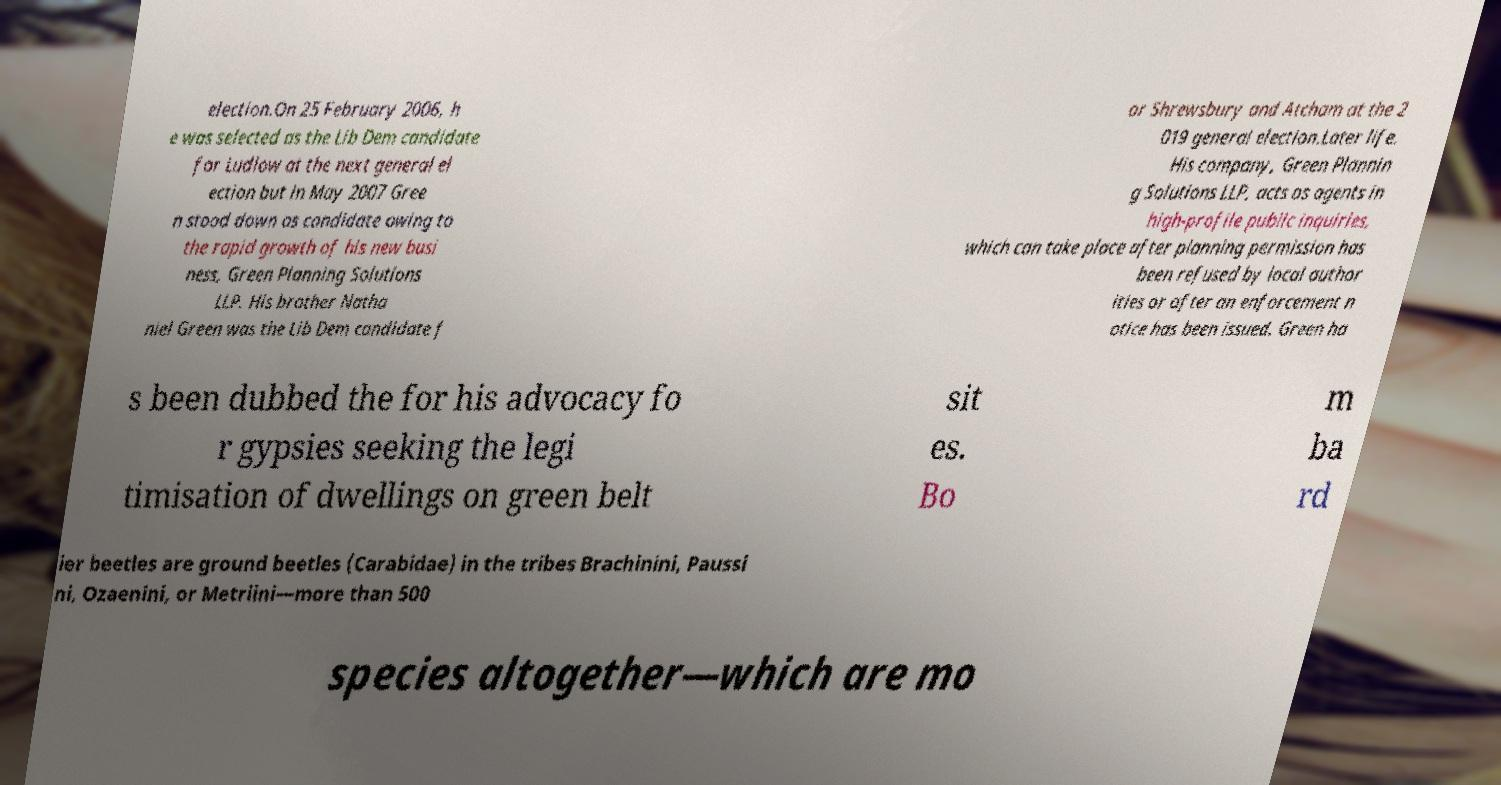What messages or text are displayed in this image? I need them in a readable, typed format. election.On 25 February 2006, h e was selected as the Lib Dem candidate for Ludlow at the next general el ection but in May 2007 Gree n stood down as candidate owing to the rapid growth of his new busi ness, Green Planning Solutions LLP. His brother Natha niel Green was the Lib Dem candidate f or Shrewsbury and Atcham at the 2 019 general election.Later life. His company, Green Plannin g Solutions LLP, acts as agents in high-profile public inquiries, which can take place after planning permission has been refused by local author ities or after an enforcement n otice has been issued. Green ha s been dubbed the for his advocacy fo r gypsies seeking the legi timisation of dwellings on green belt sit es. Bo m ba rd ier beetles are ground beetles (Carabidae) in the tribes Brachinini, Paussi ni, Ozaenini, or Metriini—more than 500 species altogether—which are mo 